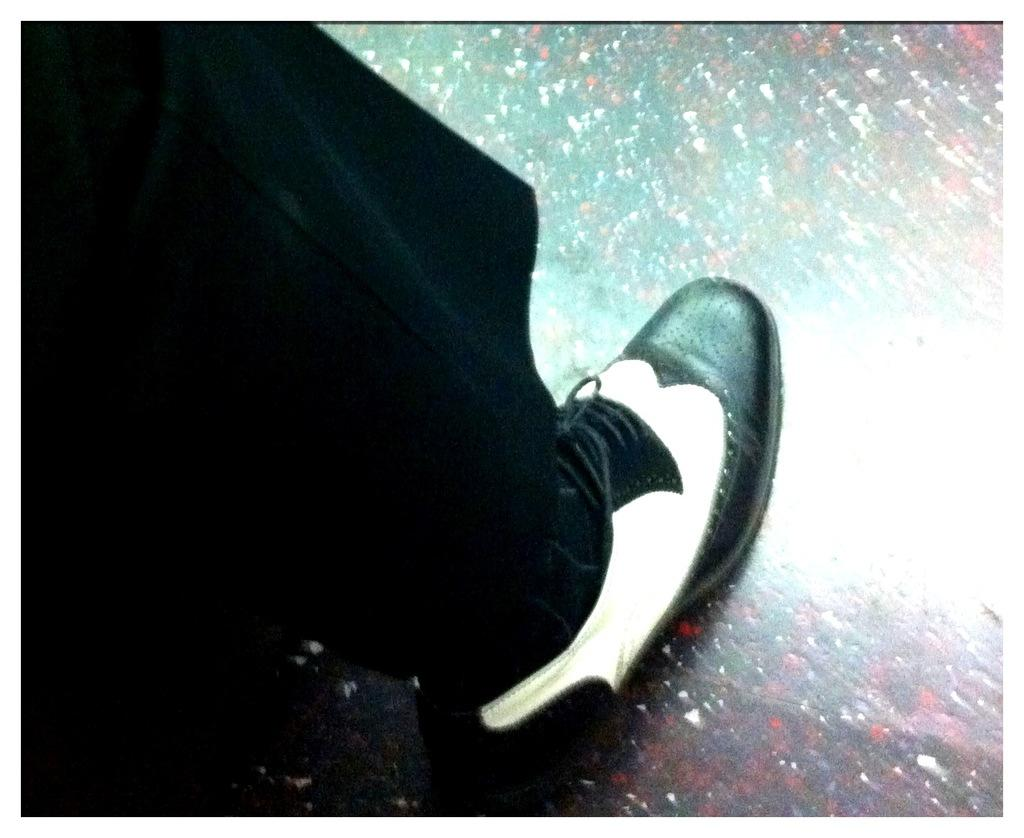What part of a person's body is visible in the image? There is a person's leg visible in the image. What is the leg wearing? The leg is wearing a shoe. How much money is being held by the person's leg in the image? There is no money visible in the image; only a leg wearing a shoe is present. 